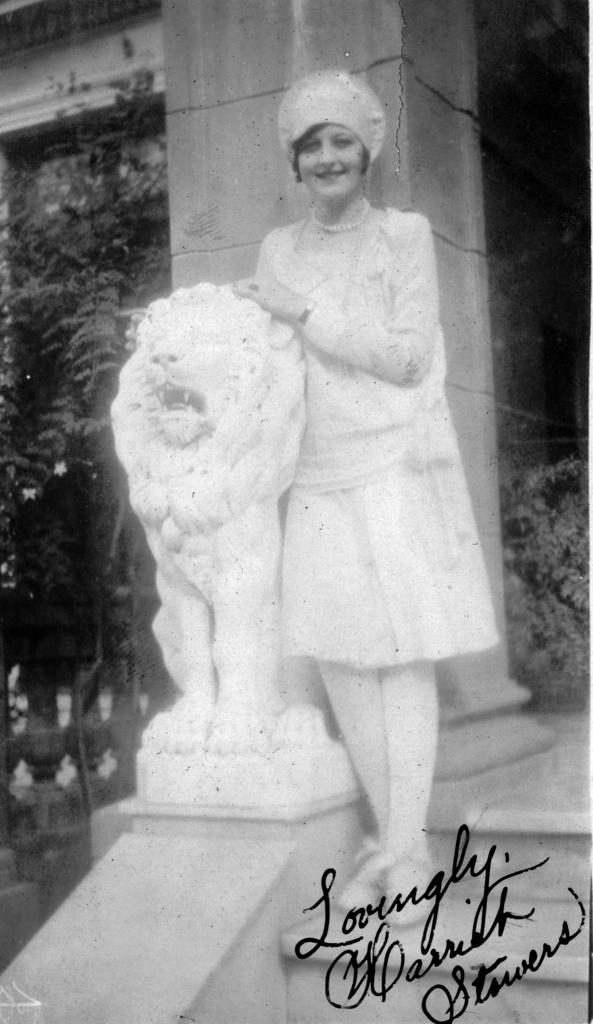What is the color scheme of the image? The image is black and white. Who is present in the image? There is a woman in the image. What is the woman standing near? The woman is standing near a lion statue. Can you describe the location of the lion statue? The lion statue is on a stair. What can be seen in the background of the image? There is a pillar, trees, and a building in the background of the image. What type of song is the woman singing in the image? There is no indication in the image that the woman is singing, so it cannot be determined from the picture. 